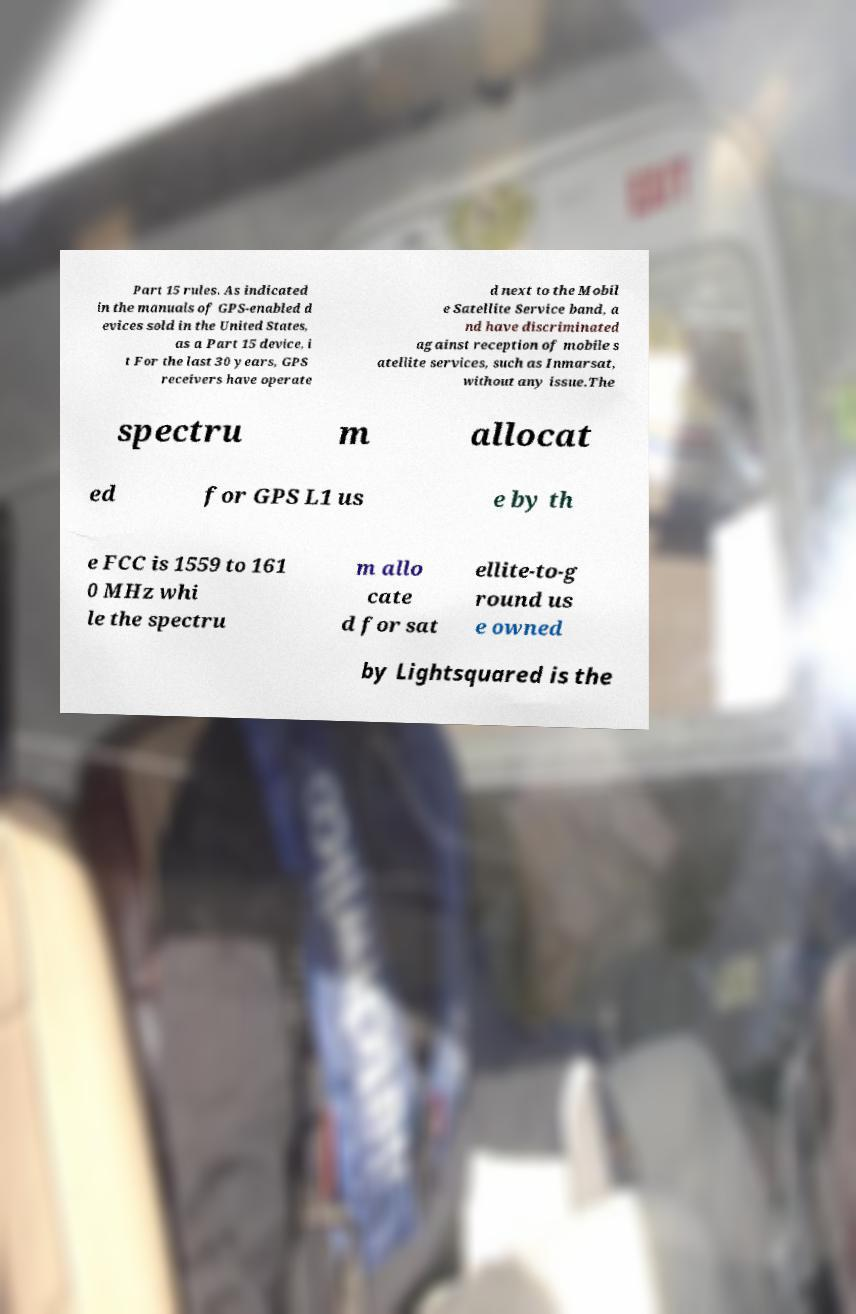There's text embedded in this image that I need extracted. Can you transcribe it verbatim? Part 15 rules. As indicated in the manuals of GPS-enabled d evices sold in the United States, as a Part 15 device, i t For the last 30 years, GPS receivers have operate d next to the Mobil e Satellite Service band, a nd have discriminated against reception of mobile s atellite services, such as Inmarsat, without any issue.The spectru m allocat ed for GPS L1 us e by th e FCC is 1559 to 161 0 MHz whi le the spectru m allo cate d for sat ellite-to-g round us e owned by Lightsquared is the 